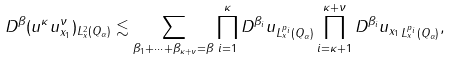<formula> <loc_0><loc_0><loc_500><loc_500>\| D ^ { \beta } ( u ^ { \kappa } u ^ { \nu } _ { x _ { 1 } } ) \| _ { L ^ { 2 } _ { x } ( Q _ { \alpha } ) } \lesssim \sum _ { \beta _ { 1 } + \dots + \beta _ { \kappa + \nu } = \beta } \prod ^ { \kappa } _ { i = 1 } \| D ^ { \beta _ { i } } u \| _ { L ^ { p _ { i } } _ { x } ( Q _ { \alpha } ) } \prod ^ { \kappa + \nu } _ { i = \kappa + 1 } \| D ^ { \beta _ { i } } u _ { x _ { 1 } } \| _ { L ^ { p _ { i } } _ { x } ( Q _ { \alpha } ) } ,</formula> 